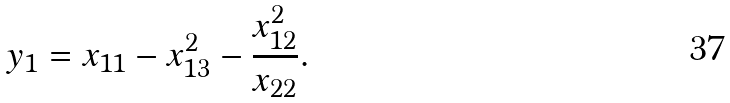<formula> <loc_0><loc_0><loc_500><loc_500>y _ { 1 } = x _ { 1 1 } - x _ { 1 3 } ^ { 2 } - \frac { x ^ { 2 } _ { 1 2 } } { x _ { 2 2 } } .</formula> 